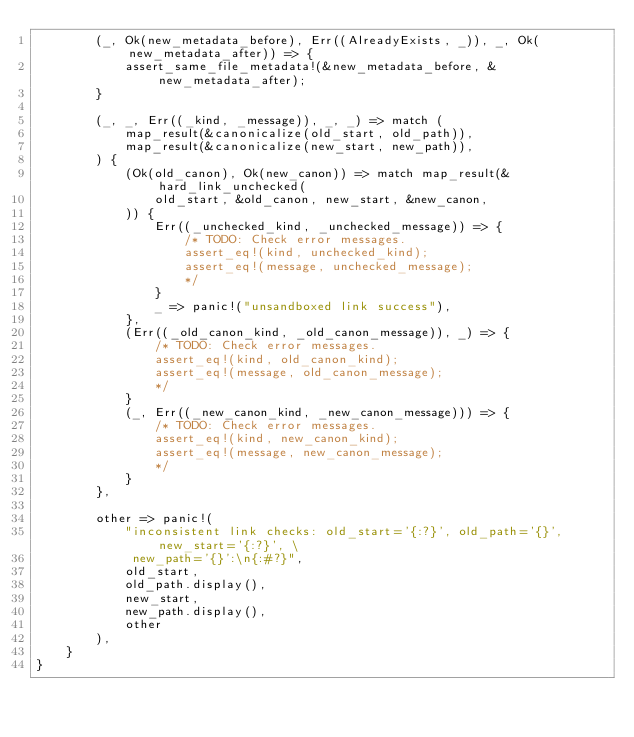Convert code to text. <code><loc_0><loc_0><loc_500><loc_500><_Rust_>        (_, Ok(new_metadata_before), Err((AlreadyExists, _)), _, Ok(new_metadata_after)) => {
            assert_same_file_metadata!(&new_metadata_before, &new_metadata_after);
        }

        (_, _, Err((_kind, _message)), _, _) => match (
            map_result(&canonicalize(old_start, old_path)),
            map_result(&canonicalize(new_start, new_path)),
        ) {
            (Ok(old_canon), Ok(new_canon)) => match map_result(&hard_link_unchecked(
                old_start, &old_canon, new_start, &new_canon,
            )) {
                Err((_unchecked_kind, _unchecked_message)) => {
                    /* TODO: Check error messages.
                    assert_eq!(kind, unchecked_kind);
                    assert_eq!(message, unchecked_message);
                    */
                }
                _ => panic!("unsandboxed link success"),
            },
            (Err((_old_canon_kind, _old_canon_message)), _) => {
                /* TODO: Check error messages.
                assert_eq!(kind, old_canon_kind);
                assert_eq!(message, old_canon_message);
                */
            }
            (_, Err((_new_canon_kind, _new_canon_message))) => {
                /* TODO: Check error messages.
                assert_eq!(kind, new_canon_kind);
                assert_eq!(message, new_canon_message);
                */
            }
        },

        other => panic!(
            "inconsistent link checks: old_start='{:?}', old_path='{}', new_start='{:?}', \
             new_path='{}':\n{:#?}",
            old_start,
            old_path.display(),
            new_start,
            new_path.display(),
            other
        ),
    }
}
</code> 